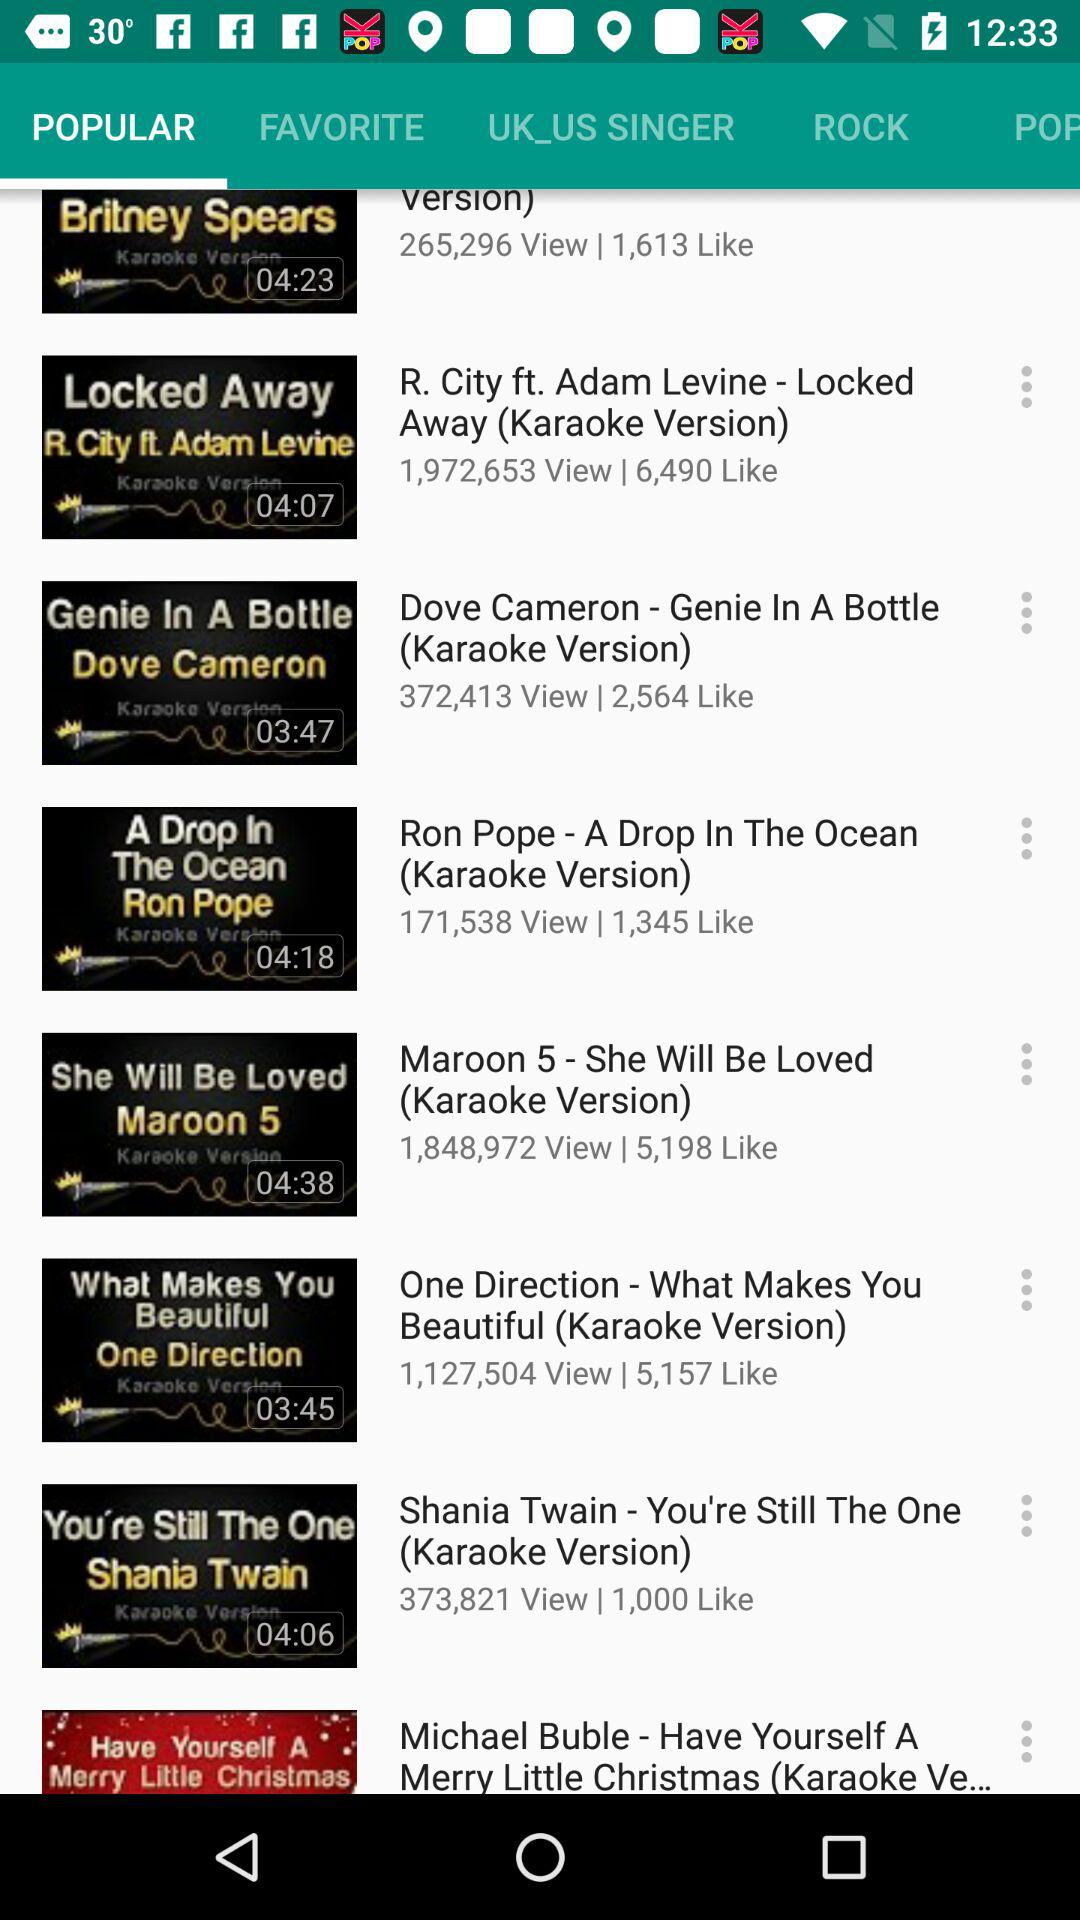How many people like Maroon 5? There are 5,198 people who like "Maroon 5". 